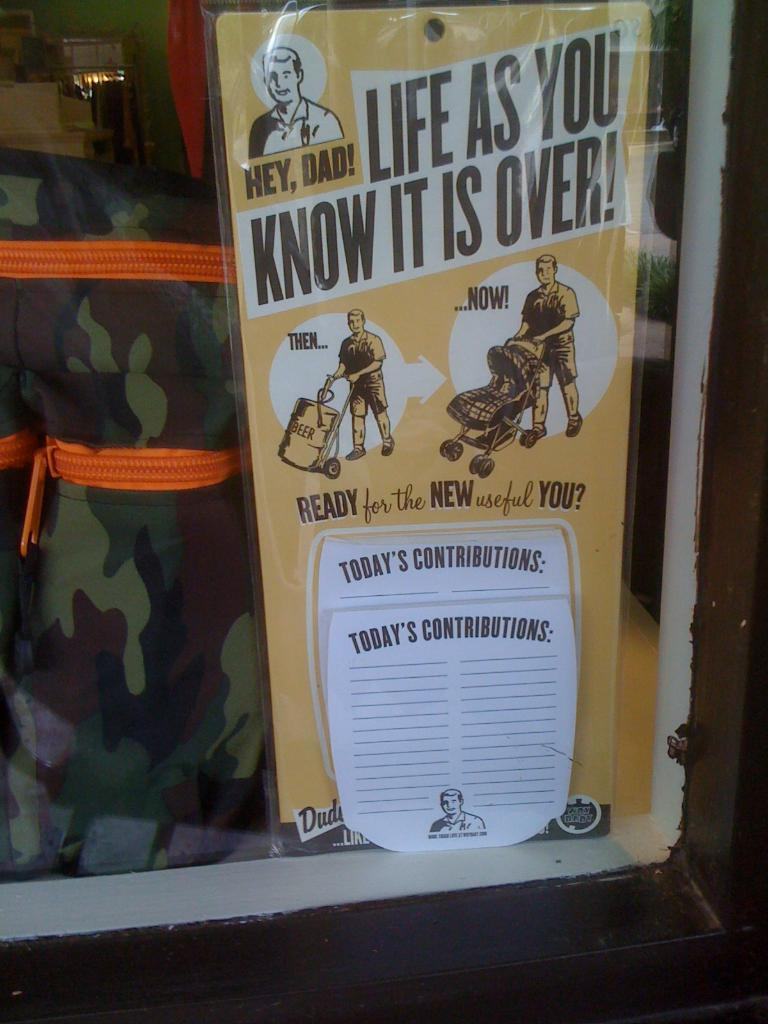<image>
Present a compact description of the photo's key features. A sign showing a new dad says Life as you know it is over. 